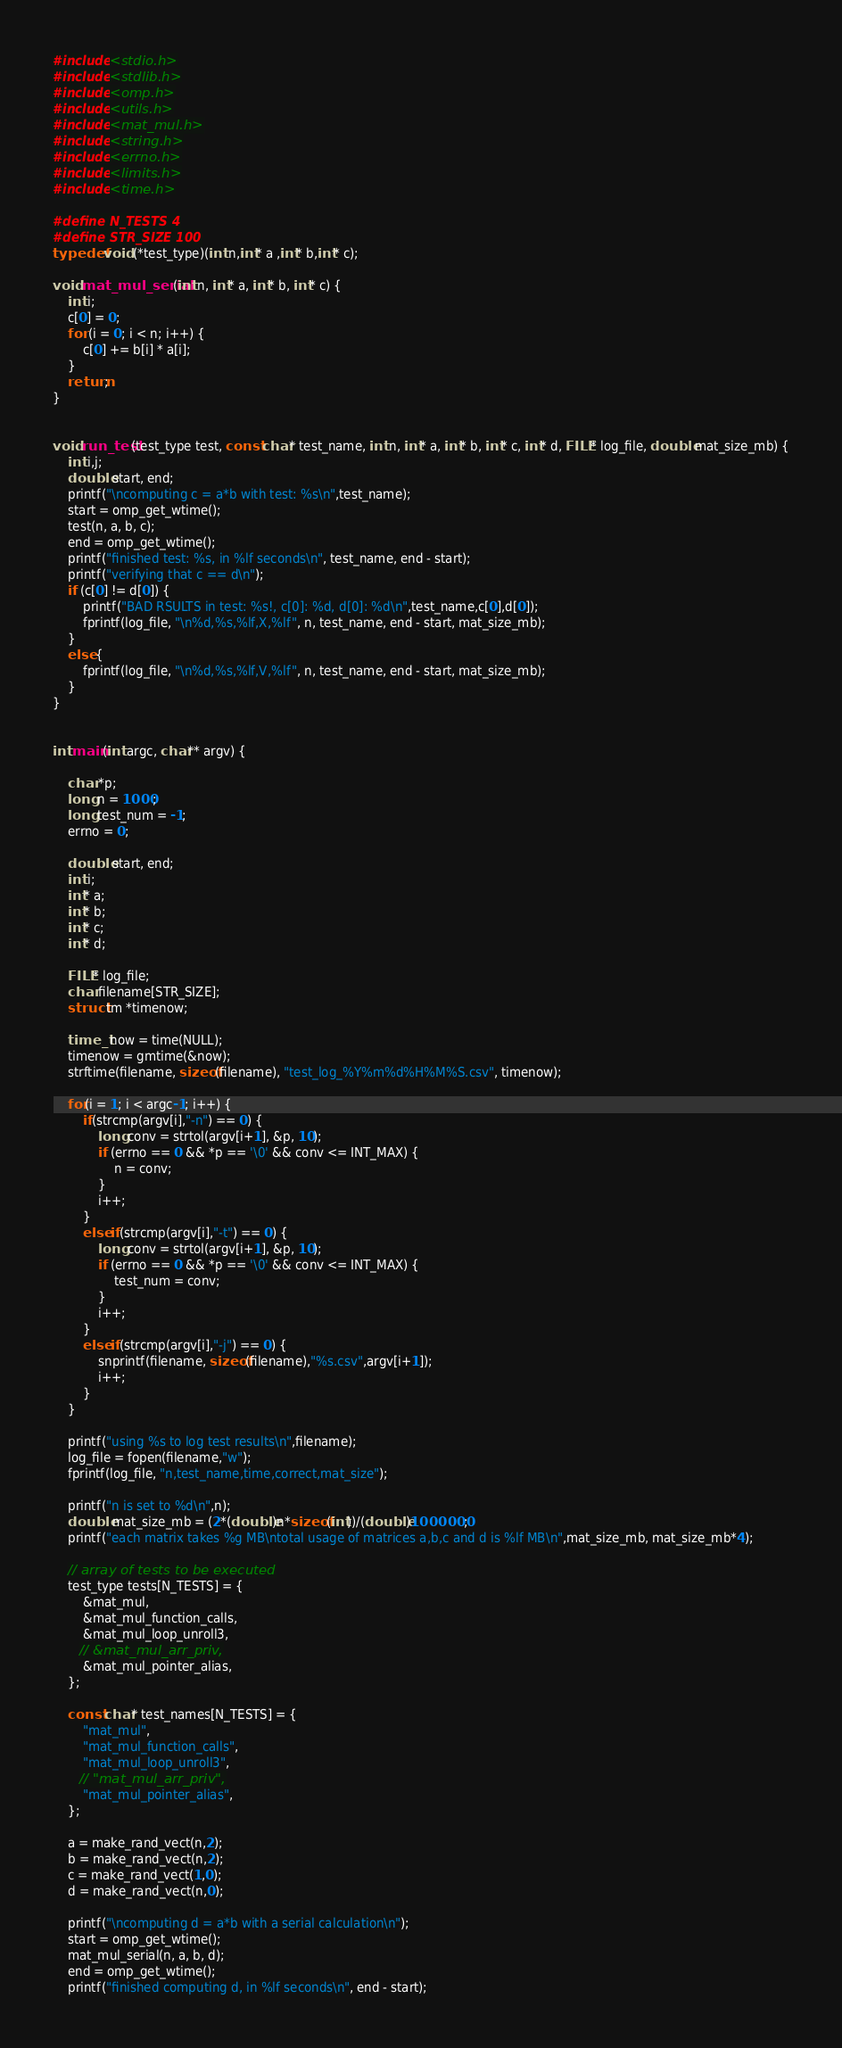<code> <loc_0><loc_0><loc_500><loc_500><_C_>#include <stdio.h>
#include <stdlib.h>
#include <omp.h>
#include <utils.h>
#include <mat_mul.h>
#include <string.h>
#include <errno.h>
#include <limits.h>
#include <time.h>

#define N_TESTS 4
#define STR_SIZE 100
typedef void (*test_type)(int n,int* a ,int* b,int* c);

void mat_mul_serial(int n, int* a, int* b, int* c) {
    int i;
    c[0] = 0;
    for (i = 0; i < n; i++) {
        c[0] += b[i] * a[i];
    }
    return;
}


void run_test(test_type test, const char* test_name, int n, int* a, int* b, int* c, int* d, FILE* log_file, double mat_size_mb) {
    int i,j;
    double start, end;
    printf("\ncomputing c = a*b with test: %s\n",test_name);        
    start = omp_get_wtime();
    test(n, a, b, c);
    end = omp_get_wtime();
    printf("finished test: %s, in %lf seconds\n", test_name, end - start);
    printf("verifying that c == d\n"); 
    if (c[0] != d[0]) {
        printf("BAD RSULTS in test: %s!, c[0]: %d, d[0]: %d\n",test_name,c[0],d[0]);
        fprintf(log_file, "\n%d,%s,%lf,X,%lf", n, test_name, end - start, mat_size_mb);             
    }
    else {
        fprintf(log_file, "\n%d,%s,%lf,V,%lf", n, test_name, end - start, mat_size_mb);           
    }
}


int main(int argc, char** argv) {

    char *p;
    long n = 1000;
    long test_num = -1;
    errno = 0;
    
    double start, end;
    int i;
    int* a; 
    int* b;
    int* c;
    int* d;

    FILE* log_file;
    char filename[STR_SIZE];
    struct tm *timenow;

    time_t now = time(NULL);
    timenow = gmtime(&now);
    strftime(filename, sizeof(filename), "test_log_%Y%m%d%H%M%S.csv", timenow);
    
    for(i = 1; i < argc-1; i++) {
        if(strcmp(argv[i],"-n") == 0) {
            long conv = strtol(argv[i+1], &p, 10);
            if (errno == 0 && *p == '\0' && conv <= INT_MAX) {
                n = conv;
            }
            i++;
        }
        else if(strcmp(argv[i],"-t") == 0) {
            long conv = strtol(argv[i+1], &p, 10);
            if (errno == 0 && *p == '\0' && conv <= INT_MAX) {
                test_num = conv;
            }
            i++;
        }
        else if(strcmp(argv[i],"-j") == 0) {
            snprintf(filename, sizeof(filename),"%s.csv",argv[i+1]);
            i++;
        }
    }
    
    printf("using %s to log test results\n",filename);
    log_file = fopen(filename,"w");    
    fprintf(log_file, "n,test_name,time,correct,mat_size");
    
    printf("n is set to %d\n",n);    
    double mat_size_mb = (2*(double)n*sizeof(int))/(double)1000000;
    printf("each matrix takes %g MB\ntotal usage of matrices a,b,c and d is %lf MB\n",mat_size_mb, mat_size_mb*4);    
    
    // array of tests to be executed
    test_type tests[N_TESTS] = {
        &mat_mul,
        &mat_mul_function_calls,
        &mat_mul_loop_unroll3,
       // &mat_mul_arr_priv,
        &mat_mul_pointer_alias,
    };

    const char* test_names[N_TESTS] = { 
        "mat_mul",
        "mat_mul_function_calls",
        "mat_mul_loop_unroll3",
       // "mat_mul_arr_priv",
        "mat_mul_pointer_alias",
    };

    a = make_rand_vect(n,2);
    b = make_rand_vect(n,2);
    c = make_rand_vect(1,0);
    d = make_rand_vect(n,0);
    
    printf("\ncomputing d = a*b with a serial calculation\n");
    start = omp_get_wtime();
    mat_mul_serial(n, a, b, d);
    end = omp_get_wtime();
    printf("finished computing d, in %lf seconds\n", end - start);</code> 